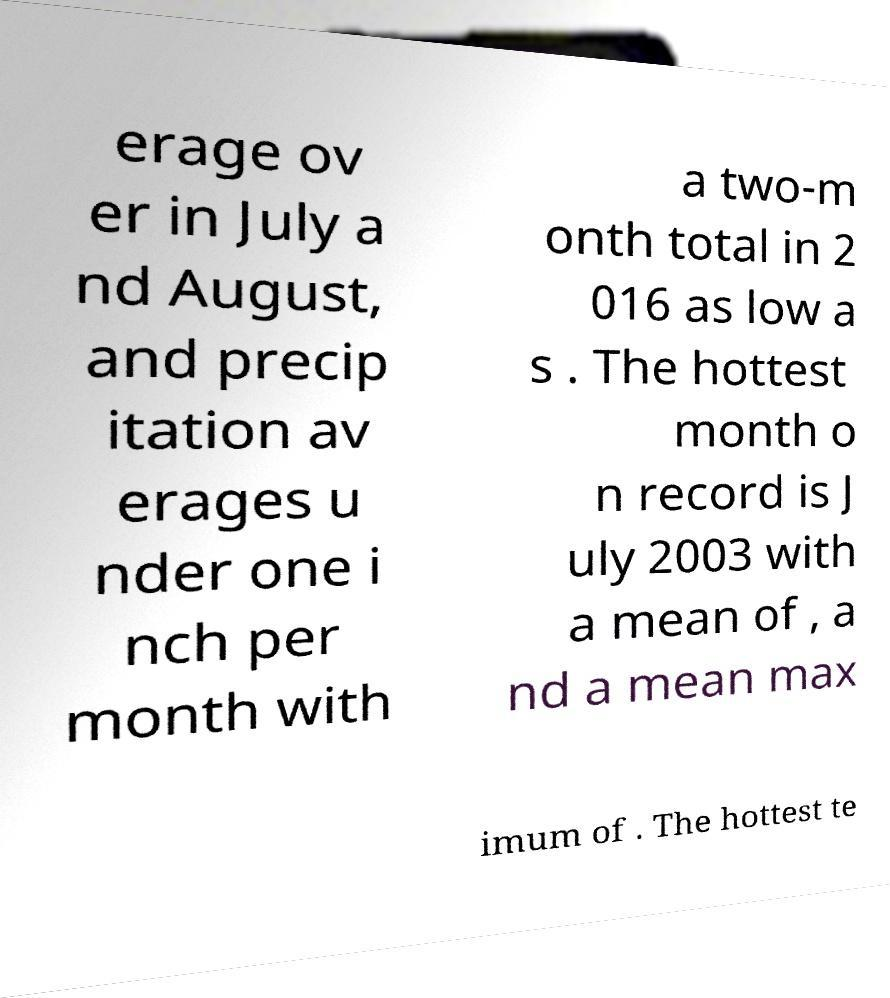Could you assist in decoding the text presented in this image and type it out clearly? erage ov er in July a nd August, and precip itation av erages u nder one i nch per month with a two-m onth total in 2 016 as low a s . The hottest month o n record is J uly 2003 with a mean of , a nd a mean max imum of . The hottest te 